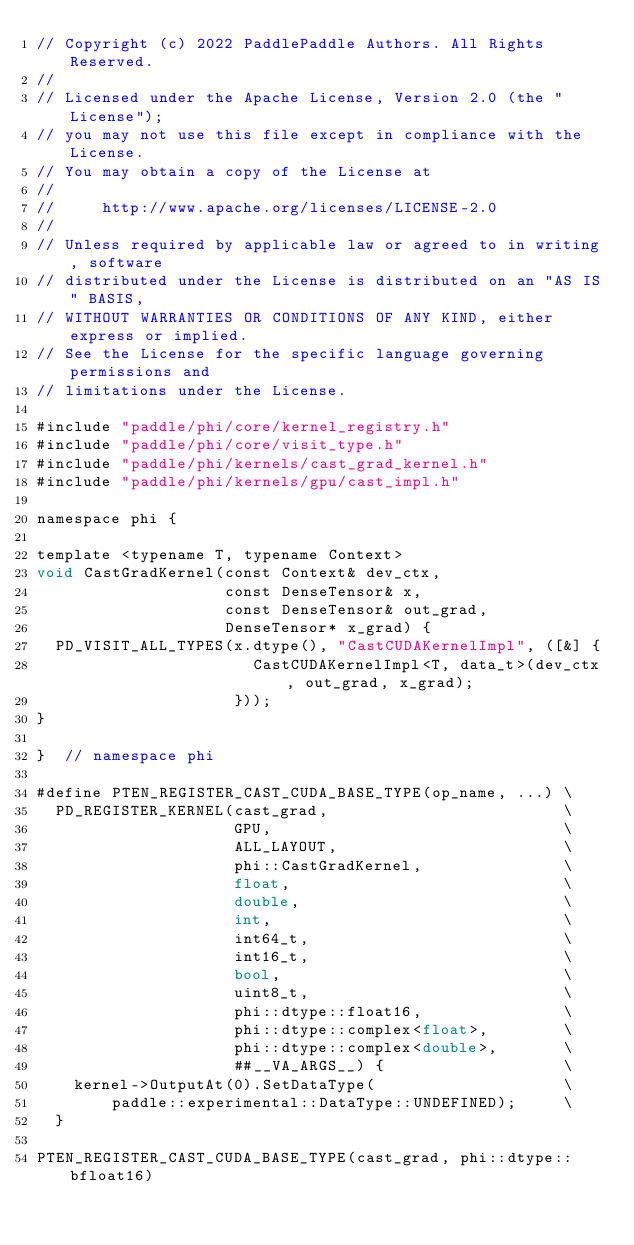<code> <loc_0><loc_0><loc_500><loc_500><_Cuda_>// Copyright (c) 2022 PaddlePaddle Authors. All Rights Reserved.
//
// Licensed under the Apache License, Version 2.0 (the "License");
// you may not use this file except in compliance with the License.
// You may obtain a copy of the License at
//
//     http://www.apache.org/licenses/LICENSE-2.0
//
// Unless required by applicable law or agreed to in writing, software
// distributed under the License is distributed on an "AS IS" BASIS,
// WITHOUT WARRANTIES OR CONDITIONS OF ANY KIND, either express or implied.
// See the License for the specific language governing permissions and
// limitations under the License.

#include "paddle/phi/core/kernel_registry.h"
#include "paddle/phi/core/visit_type.h"
#include "paddle/phi/kernels/cast_grad_kernel.h"
#include "paddle/phi/kernels/gpu/cast_impl.h"

namespace phi {

template <typename T, typename Context>
void CastGradKernel(const Context& dev_ctx,
                    const DenseTensor& x,
                    const DenseTensor& out_grad,
                    DenseTensor* x_grad) {
  PD_VISIT_ALL_TYPES(x.dtype(), "CastCUDAKernelImpl", ([&] {
                       CastCUDAKernelImpl<T, data_t>(dev_ctx, out_grad, x_grad);
                     }));
}

}  // namespace phi

#define PTEN_REGISTER_CAST_CUDA_BASE_TYPE(op_name, ...) \
  PD_REGISTER_KERNEL(cast_grad,                         \
                     GPU,                               \
                     ALL_LAYOUT,                        \
                     phi::CastGradKernel,               \
                     float,                             \
                     double,                            \
                     int,                               \
                     int64_t,                           \
                     int16_t,                           \
                     bool,                              \
                     uint8_t,                           \
                     phi::dtype::float16,               \
                     phi::dtype::complex<float>,        \
                     phi::dtype::complex<double>,       \
                     ##__VA_ARGS__) {                   \
    kernel->OutputAt(0).SetDataType(                    \
        paddle::experimental::DataType::UNDEFINED);     \
  }

PTEN_REGISTER_CAST_CUDA_BASE_TYPE(cast_grad, phi::dtype::bfloat16)
</code> 